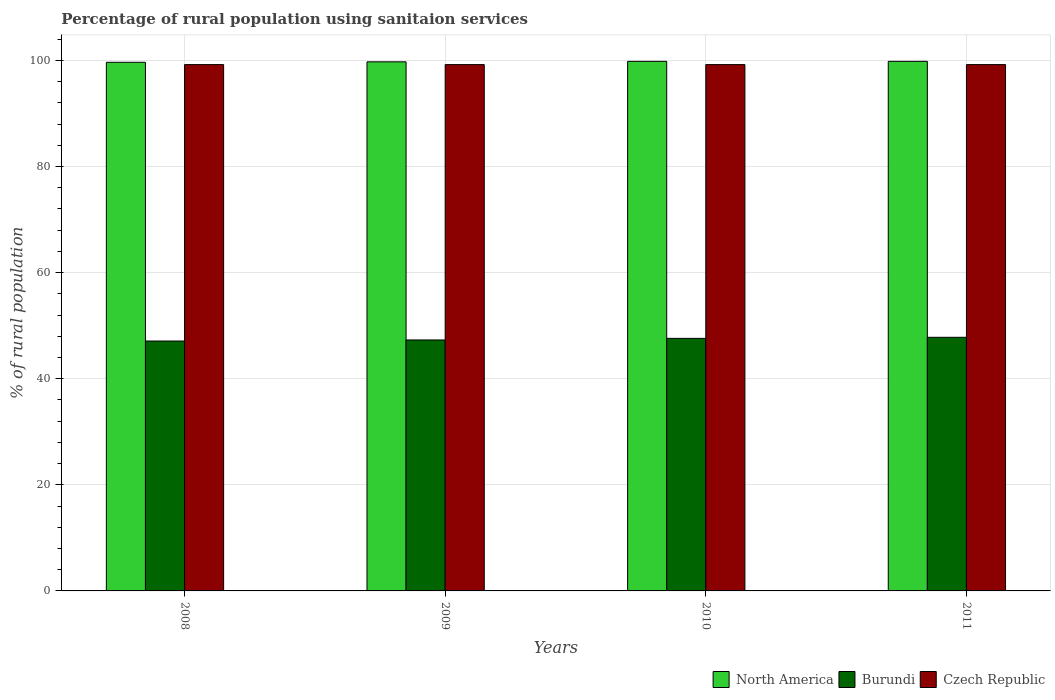Are the number of bars per tick equal to the number of legend labels?
Provide a short and direct response. Yes. How many bars are there on the 2nd tick from the right?
Provide a short and direct response. 3. What is the label of the 2nd group of bars from the left?
Ensure brevity in your answer.  2009. What is the percentage of rural population using sanitaion services in North America in 2008?
Offer a terse response. 99.63. Across all years, what is the maximum percentage of rural population using sanitaion services in Burundi?
Provide a succinct answer. 47.8. Across all years, what is the minimum percentage of rural population using sanitaion services in Czech Republic?
Provide a short and direct response. 99.2. In which year was the percentage of rural population using sanitaion services in Burundi maximum?
Your response must be concise. 2011. What is the total percentage of rural population using sanitaion services in Burundi in the graph?
Keep it short and to the point. 189.8. What is the difference between the percentage of rural population using sanitaion services in Czech Republic in 2011 and the percentage of rural population using sanitaion services in Burundi in 2008?
Offer a terse response. 52.1. What is the average percentage of rural population using sanitaion services in Burundi per year?
Provide a short and direct response. 47.45. In the year 2011, what is the difference between the percentage of rural population using sanitaion services in Burundi and percentage of rural population using sanitaion services in North America?
Provide a short and direct response. -52.01. In how many years, is the percentage of rural population using sanitaion services in North America greater than 68 %?
Keep it short and to the point. 4. What is the ratio of the percentage of rural population using sanitaion services in Burundi in 2008 to that in 2011?
Give a very brief answer. 0.99. Is the difference between the percentage of rural population using sanitaion services in Burundi in 2009 and 2010 greater than the difference between the percentage of rural population using sanitaion services in North America in 2009 and 2010?
Offer a very short reply. No. What is the difference between the highest and the second highest percentage of rural population using sanitaion services in North America?
Provide a succinct answer. 0. What is the difference between the highest and the lowest percentage of rural population using sanitaion services in North America?
Offer a terse response. 0.18. In how many years, is the percentage of rural population using sanitaion services in Czech Republic greater than the average percentage of rural population using sanitaion services in Czech Republic taken over all years?
Provide a short and direct response. 0. Is the sum of the percentage of rural population using sanitaion services in Burundi in 2009 and 2010 greater than the maximum percentage of rural population using sanitaion services in Czech Republic across all years?
Give a very brief answer. No. What does the 1st bar from the left in 2010 represents?
Your response must be concise. North America. What does the 1st bar from the right in 2009 represents?
Offer a terse response. Czech Republic. Is it the case that in every year, the sum of the percentage of rural population using sanitaion services in Burundi and percentage of rural population using sanitaion services in North America is greater than the percentage of rural population using sanitaion services in Czech Republic?
Give a very brief answer. Yes. How many bars are there?
Provide a short and direct response. 12. Are all the bars in the graph horizontal?
Ensure brevity in your answer.  No. How many years are there in the graph?
Offer a terse response. 4. What is the difference between two consecutive major ticks on the Y-axis?
Keep it short and to the point. 20. Are the values on the major ticks of Y-axis written in scientific E-notation?
Provide a succinct answer. No. Does the graph contain grids?
Your answer should be very brief. Yes. How are the legend labels stacked?
Offer a very short reply. Horizontal. What is the title of the graph?
Give a very brief answer. Percentage of rural population using sanitaion services. What is the label or title of the Y-axis?
Keep it short and to the point. % of rural population. What is the % of rural population of North America in 2008?
Give a very brief answer. 99.63. What is the % of rural population in Burundi in 2008?
Give a very brief answer. 47.1. What is the % of rural population in Czech Republic in 2008?
Ensure brevity in your answer.  99.2. What is the % of rural population in North America in 2009?
Provide a short and direct response. 99.72. What is the % of rural population in Burundi in 2009?
Keep it short and to the point. 47.3. What is the % of rural population in Czech Republic in 2009?
Your answer should be very brief. 99.2. What is the % of rural population in North America in 2010?
Your response must be concise. 99.81. What is the % of rural population in Burundi in 2010?
Ensure brevity in your answer.  47.6. What is the % of rural population of Czech Republic in 2010?
Your answer should be very brief. 99.2. What is the % of rural population of North America in 2011?
Your answer should be very brief. 99.81. What is the % of rural population in Burundi in 2011?
Your answer should be very brief. 47.8. What is the % of rural population of Czech Republic in 2011?
Offer a terse response. 99.2. Across all years, what is the maximum % of rural population of North America?
Ensure brevity in your answer.  99.81. Across all years, what is the maximum % of rural population in Burundi?
Provide a succinct answer. 47.8. Across all years, what is the maximum % of rural population in Czech Republic?
Keep it short and to the point. 99.2. Across all years, what is the minimum % of rural population of North America?
Give a very brief answer. 99.63. Across all years, what is the minimum % of rural population of Burundi?
Keep it short and to the point. 47.1. Across all years, what is the minimum % of rural population of Czech Republic?
Your answer should be very brief. 99.2. What is the total % of rural population in North America in the graph?
Offer a terse response. 398.98. What is the total % of rural population in Burundi in the graph?
Make the answer very short. 189.8. What is the total % of rural population in Czech Republic in the graph?
Provide a succinct answer. 396.8. What is the difference between the % of rural population of North America in 2008 and that in 2009?
Your answer should be very brief. -0.09. What is the difference between the % of rural population of Burundi in 2008 and that in 2009?
Offer a terse response. -0.2. What is the difference between the % of rural population of North America in 2008 and that in 2010?
Your answer should be very brief. -0.18. What is the difference between the % of rural population in Czech Republic in 2008 and that in 2010?
Your answer should be compact. 0. What is the difference between the % of rural population of North America in 2008 and that in 2011?
Provide a succinct answer. -0.18. What is the difference between the % of rural population in North America in 2009 and that in 2010?
Offer a very short reply. -0.09. What is the difference between the % of rural population in Burundi in 2009 and that in 2010?
Your answer should be very brief. -0.3. What is the difference between the % of rural population in North America in 2009 and that in 2011?
Ensure brevity in your answer.  -0.09. What is the difference between the % of rural population of Czech Republic in 2010 and that in 2011?
Give a very brief answer. 0. What is the difference between the % of rural population of North America in 2008 and the % of rural population of Burundi in 2009?
Provide a succinct answer. 52.33. What is the difference between the % of rural population of North America in 2008 and the % of rural population of Czech Republic in 2009?
Give a very brief answer. 0.43. What is the difference between the % of rural population of Burundi in 2008 and the % of rural population of Czech Republic in 2009?
Provide a short and direct response. -52.1. What is the difference between the % of rural population of North America in 2008 and the % of rural population of Burundi in 2010?
Keep it short and to the point. 52.03. What is the difference between the % of rural population in North America in 2008 and the % of rural population in Czech Republic in 2010?
Provide a short and direct response. 0.43. What is the difference between the % of rural population of Burundi in 2008 and the % of rural population of Czech Republic in 2010?
Provide a succinct answer. -52.1. What is the difference between the % of rural population of North America in 2008 and the % of rural population of Burundi in 2011?
Provide a short and direct response. 51.83. What is the difference between the % of rural population in North America in 2008 and the % of rural population in Czech Republic in 2011?
Offer a terse response. 0.43. What is the difference between the % of rural population in Burundi in 2008 and the % of rural population in Czech Republic in 2011?
Offer a very short reply. -52.1. What is the difference between the % of rural population of North America in 2009 and the % of rural population of Burundi in 2010?
Provide a short and direct response. 52.12. What is the difference between the % of rural population of North America in 2009 and the % of rural population of Czech Republic in 2010?
Provide a succinct answer. 0.52. What is the difference between the % of rural population of Burundi in 2009 and the % of rural population of Czech Republic in 2010?
Make the answer very short. -51.9. What is the difference between the % of rural population of North America in 2009 and the % of rural population of Burundi in 2011?
Ensure brevity in your answer.  51.92. What is the difference between the % of rural population of North America in 2009 and the % of rural population of Czech Republic in 2011?
Offer a terse response. 0.52. What is the difference between the % of rural population of Burundi in 2009 and the % of rural population of Czech Republic in 2011?
Offer a very short reply. -51.9. What is the difference between the % of rural population in North America in 2010 and the % of rural population in Burundi in 2011?
Your answer should be very brief. 52.01. What is the difference between the % of rural population of North America in 2010 and the % of rural population of Czech Republic in 2011?
Offer a very short reply. 0.61. What is the difference between the % of rural population of Burundi in 2010 and the % of rural population of Czech Republic in 2011?
Your answer should be compact. -51.6. What is the average % of rural population of North America per year?
Your response must be concise. 99.74. What is the average % of rural population in Burundi per year?
Offer a terse response. 47.45. What is the average % of rural population of Czech Republic per year?
Give a very brief answer. 99.2. In the year 2008, what is the difference between the % of rural population in North America and % of rural population in Burundi?
Provide a succinct answer. 52.53. In the year 2008, what is the difference between the % of rural population of North America and % of rural population of Czech Republic?
Provide a short and direct response. 0.43. In the year 2008, what is the difference between the % of rural population of Burundi and % of rural population of Czech Republic?
Your answer should be compact. -52.1. In the year 2009, what is the difference between the % of rural population of North America and % of rural population of Burundi?
Offer a very short reply. 52.42. In the year 2009, what is the difference between the % of rural population of North America and % of rural population of Czech Republic?
Offer a very short reply. 0.52. In the year 2009, what is the difference between the % of rural population of Burundi and % of rural population of Czech Republic?
Offer a terse response. -51.9. In the year 2010, what is the difference between the % of rural population of North America and % of rural population of Burundi?
Your response must be concise. 52.21. In the year 2010, what is the difference between the % of rural population of North America and % of rural population of Czech Republic?
Provide a short and direct response. 0.61. In the year 2010, what is the difference between the % of rural population in Burundi and % of rural population in Czech Republic?
Your response must be concise. -51.6. In the year 2011, what is the difference between the % of rural population in North America and % of rural population in Burundi?
Keep it short and to the point. 52.01. In the year 2011, what is the difference between the % of rural population of North America and % of rural population of Czech Republic?
Keep it short and to the point. 0.61. In the year 2011, what is the difference between the % of rural population of Burundi and % of rural population of Czech Republic?
Offer a very short reply. -51.4. What is the ratio of the % of rural population of North America in 2008 to that in 2009?
Give a very brief answer. 1. What is the ratio of the % of rural population of Czech Republic in 2008 to that in 2009?
Provide a short and direct response. 1. What is the ratio of the % of rural population of Burundi in 2008 to that in 2010?
Offer a very short reply. 0.99. What is the ratio of the % of rural population of Burundi in 2008 to that in 2011?
Give a very brief answer. 0.99. What is the ratio of the % of rural population of Czech Republic in 2008 to that in 2011?
Offer a very short reply. 1. What is the ratio of the % of rural population in Burundi in 2009 to that in 2011?
Your answer should be very brief. 0.99. What is the difference between the highest and the lowest % of rural population in North America?
Offer a very short reply. 0.18. What is the difference between the highest and the lowest % of rural population of Burundi?
Offer a very short reply. 0.7. 